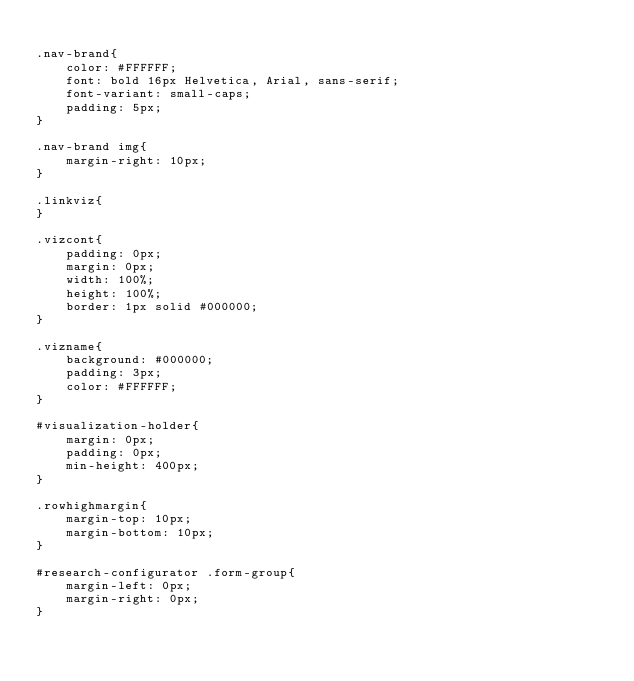Convert code to text. <code><loc_0><loc_0><loc_500><loc_500><_CSS_>
.nav-brand{
	color: #FFFFFF;
	font: bold 16px Helvetica, Arial, sans-serif;
	font-variant: small-caps;
	padding: 5px;
}

.nav-brand img{
	margin-right: 10px;
}

.linkviz{
}

.vizcont{
	padding: 0px;
	margin: 0px;
	width: 100%;
	height: 100%;
	border: 1px solid #000000;
}

.vizname{
	background: #000000;
	padding: 3px;
	color: #FFFFFF;
}

#visualization-holder{
	margin: 0px;
	padding: 0px;
	min-height: 400px;
}

.rowhighmargin{
	margin-top: 10px;
	margin-bottom: 10px;
}

#research-configurator .form-group{
	margin-left: 0px;
	margin-right: 0px;
}</code> 